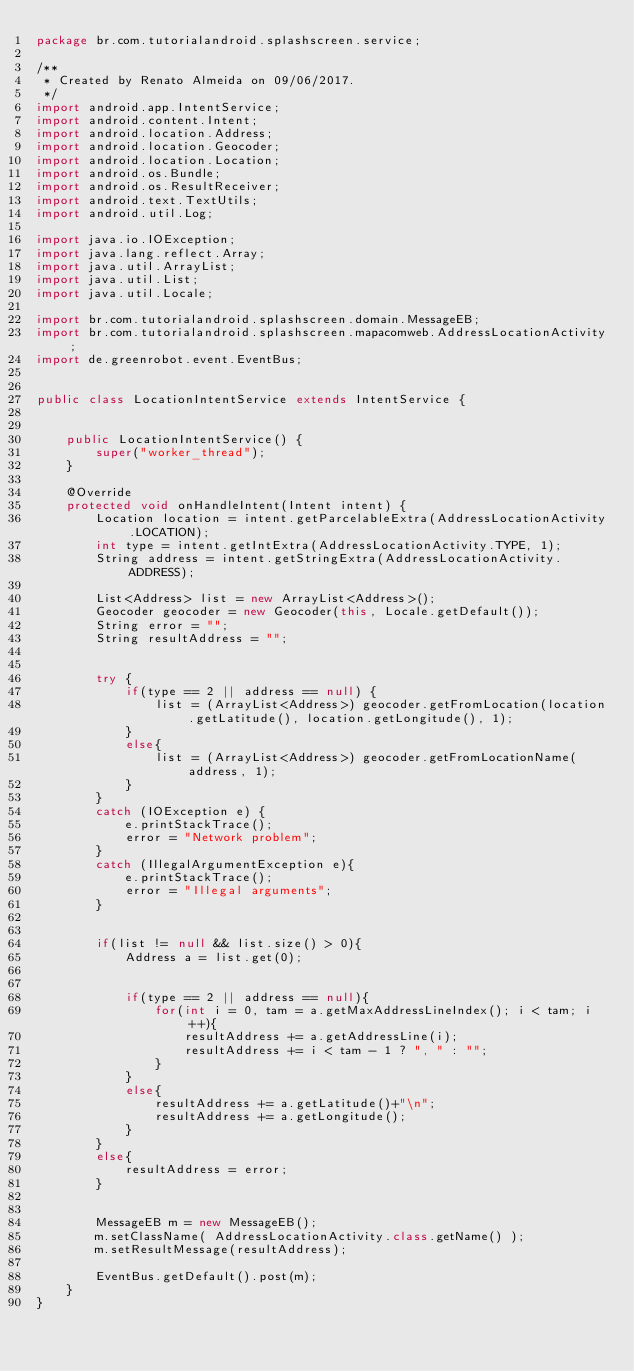Convert code to text. <code><loc_0><loc_0><loc_500><loc_500><_Java_>package br.com.tutorialandroid.splashscreen.service;

/**
 * Created by Renato Almeida on 09/06/2017.
 */
import android.app.IntentService;
import android.content.Intent;
import android.location.Address;
import android.location.Geocoder;
import android.location.Location;
import android.os.Bundle;
import android.os.ResultReceiver;
import android.text.TextUtils;
import android.util.Log;

import java.io.IOException;
import java.lang.reflect.Array;
import java.util.ArrayList;
import java.util.List;
import java.util.Locale;

import br.com.tutorialandroid.splashscreen.domain.MessageEB;
import br.com.tutorialandroid.splashscreen.mapacomweb.AddressLocationActivity;
import de.greenrobot.event.EventBus;


public class LocationIntentService extends IntentService {


    public LocationIntentService() {
        super("worker_thread");
    }

    @Override
    protected void onHandleIntent(Intent intent) {
        Location location = intent.getParcelableExtra(AddressLocationActivity.LOCATION);
        int type = intent.getIntExtra(AddressLocationActivity.TYPE, 1);
        String address = intent.getStringExtra(AddressLocationActivity.ADDRESS);

        List<Address> list = new ArrayList<Address>();
        Geocoder geocoder = new Geocoder(this, Locale.getDefault());
        String error = "";
        String resultAddress = "";


        try {
            if(type == 2 || address == null) {
                list = (ArrayList<Address>) geocoder.getFromLocation(location.getLatitude(), location.getLongitude(), 1);
            }
            else{
                list = (ArrayList<Address>) geocoder.getFromLocationName(address, 1);
            }
        }
        catch (IOException e) {
            e.printStackTrace();
            error = "Network problem";
        }
        catch (IllegalArgumentException e){
            e.printStackTrace();
            error = "Illegal arguments";
        }


        if(list != null && list.size() > 0){
            Address a = list.get(0);


            if(type == 2 || address == null){
                for(int i = 0, tam = a.getMaxAddressLineIndex(); i < tam; i++){
                    resultAddress += a.getAddressLine(i);
                    resultAddress += i < tam - 1 ? ", " : "";
                }
            }
            else{
                resultAddress += a.getLatitude()+"\n";
                resultAddress += a.getLongitude();
            }
        }
        else{
            resultAddress = error;
        }


        MessageEB m = new MessageEB();
        m.setClassName( AddressLocationActivity.class.getName() );
        m.setResultMessage(resultAddress);

        EventBus.getDefault().post(m);
    }
}
</code> 